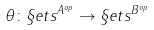<formula> <loc_0><loc_0><loc_500><loc_500>\theta \colon \S e t s ^ { A ^ { o p } } \rightarrow \S e t s ^ { B ^ { o p } }</formula> 